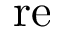<formula> <loc_0><loc_0><loc_500><loc_500>r e</formula> 